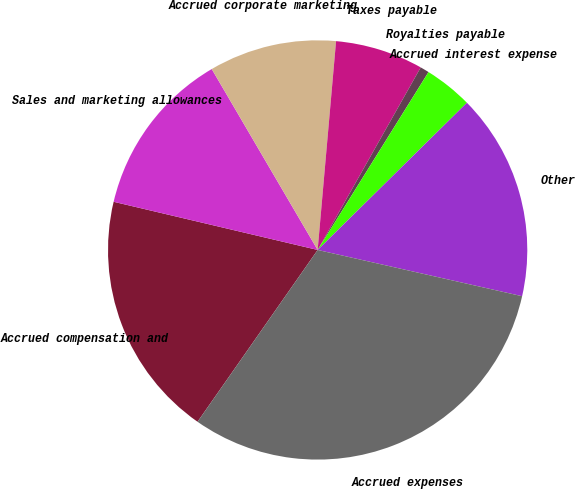Convert chart. <chart><loc_0><loc_0><loc_500><loc_500><pie_chart><fcel>Accrued compensation and<fcel>Sales and marketing allowances<fcel>Accrued corporate marketing<fcel>Taxes payable<fcel>Royalties payable<fcel>Accrued interest expense<fcel>Other<fcel>Accrued expenses<nl><fcel>18.98%<fcel>12.88%<fcel>9.83%<fcel>6.78%<fcel>0.69%<fcel>3.74%<fcel>15.93%<fcel>31.17%<nl></chart> 